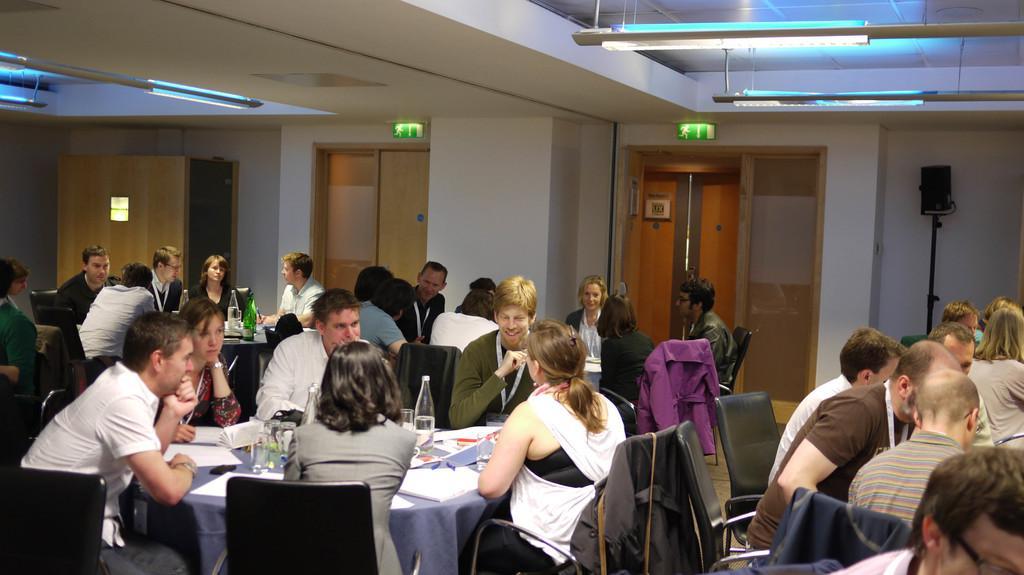Please provide a concise description of this image. In this image I can see number of people are sitting on chairs. I can also see most of them are wearing ID cards. I can also see few tables, few jackets and on these tables I can see few bottles, number of glasses, number of papers and few other things. In the background I can see few doors and on the right side of the image I can see a black colour speaker. On the top side of the image I can see few lights and few green colour sign boards on the ceiling. 